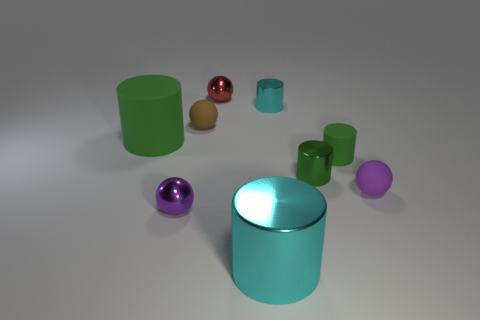Is there a big metal object? Yes, there is a large reflective cylindrical object in the center, which appears to be metallic due to its shiny surface and reflections. 